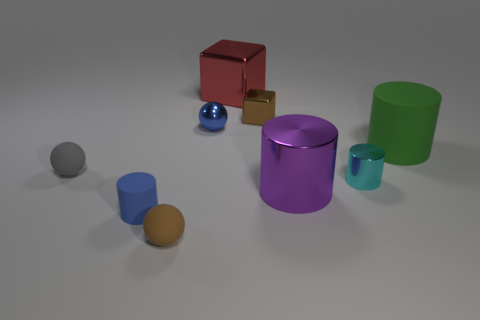What color is the small matte cylinder? blue 